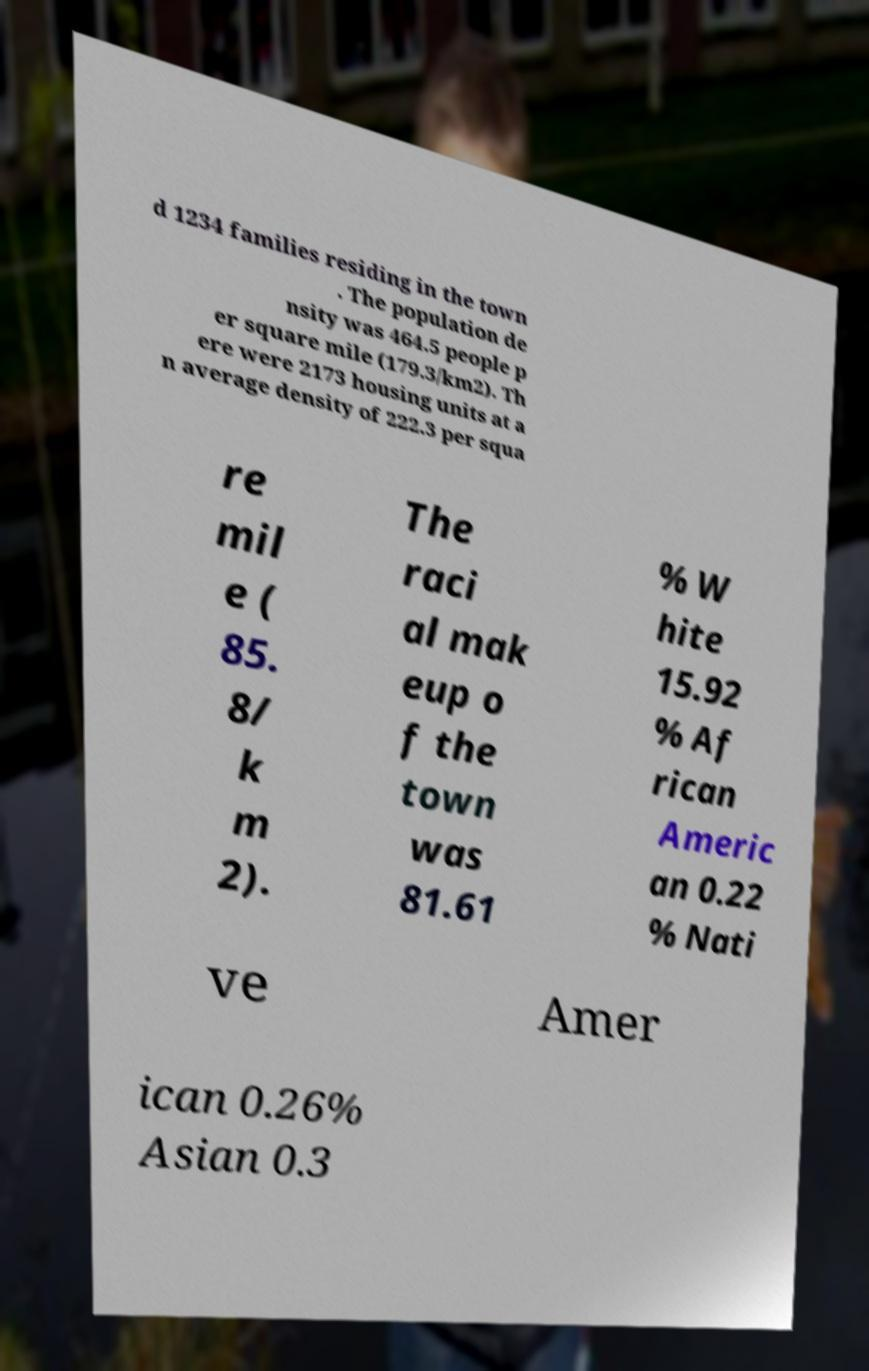Please identify and transcribe the text found in this image. d 1234 families residing in the town . The population de nsity was 464.5 people p er square mile (179.3/km2). Th ere were 2173 housing units at a n average density of 222.3 per squa re mil e ( 85. 8/ k m 2). The raci al mak eup o f the town was 81.61 % W hite 15.92 % Af rican Americ an 0.22 % Nati ve Amer ican 0.26% Asian 0.3 